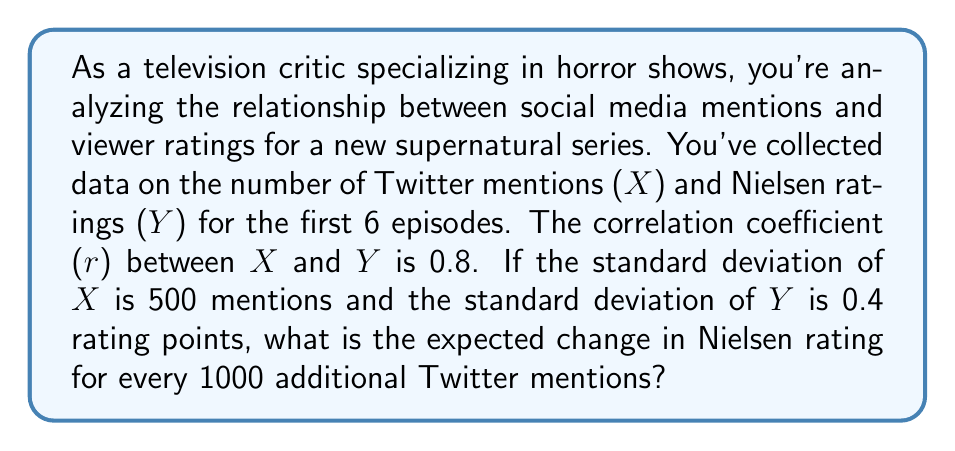Help me with this question. To solve this problem, we'll use the formula for the correlation coefficient and the relationship between correlation and regression slopes. Let's break it down step-by-step:

1) The correlation coefficient (r) is given by the formula:

   $$r = \frac{Cov(X,Y)}{s_X s_Y}$$

   where $Cov(X,Y)$ is the covariance of X and Y, and $s_X$ and $s_Y$ are the standard deviations of X and Y respectively.

2) We're given:
   $r = 0.8$
   $s_X = 500$ mentions
   $s_Y = 0.4$ rating points

3) We can rearrange the correlation coefficient formula to find the covariance:

   $$Cov(X,Y) = r \cdot s_X \cdot s_Y$$

4) Substituting our known values:

   $$Cov(X,Y) = 0.8 \cdot 500 \cdot 0.4 = 160$$

5) The slope of the regression line (b) is given by:

   $$b = \frac{Cov(X,Y)}{s_X^2}$$

6) Substituting our values:

   $$b = \frac{160}{500^2} = \frac{160}{250000} = 0.00064$$

7) This slope represents the change in Y (Nielsen rating) for a one-unit change in X (Twitter mentions). To find the change for 1000 mentions, we multiply by 1000:

   $$0.00064 \cdot 1000 = 0.64$$

Therefore, for every 1000 additional Twitter mentions, we expect the Nielsen rating to increase by 0.64 points.
Answer: 0.64 rating points 